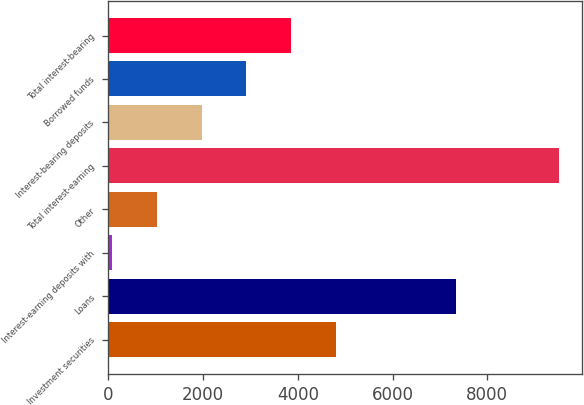<chart> <loc_0><loc_0><loc_500><loc_500><bar_chart><fcel>Investment securities<fcel>Loans<fcel>Interest-earning deposits with<fcel>Other<fcel>Total interest-earning<fcel>Interest-bearing deposits<fcel>Borrowed funds<fcel>Total interest-bearing<nl><fcel>4802.5<fcel>7333<fcel>86<fcel>1029.3<fcel>9519<fcel>1972.6<fcel>2915.9<fcel>3859.2<nl></chart> 